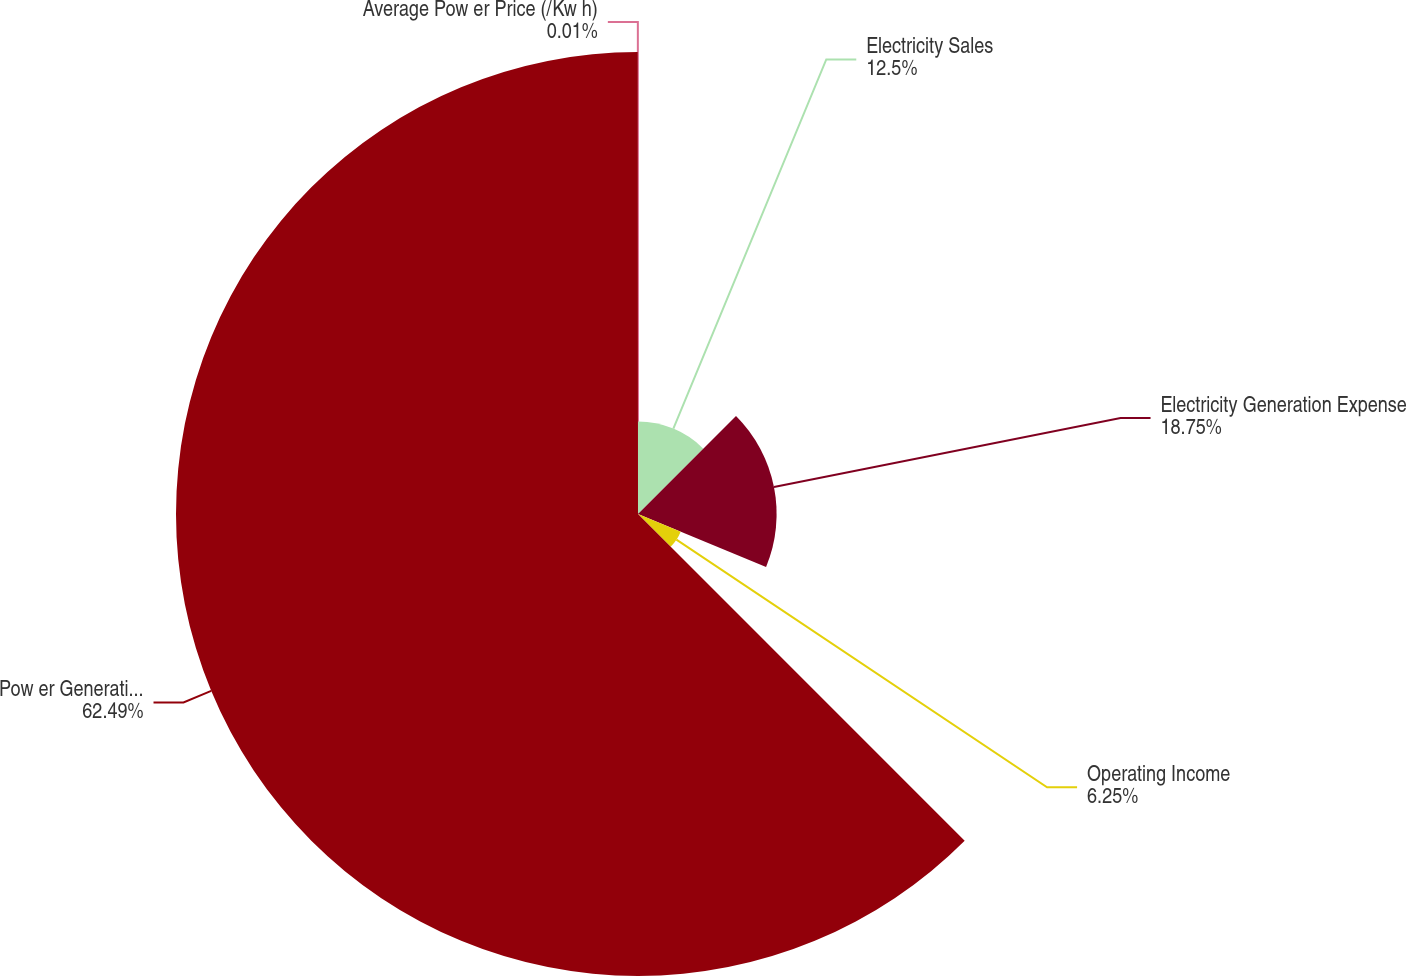<chart> <loc_0><loc_0><loc_500><loc_500><pie_chart><fcel>Electricity Sales<fcel>Electricity Generation Expense<fcel>Operating Income<fcel>Pow er Generation (GW)<fcel>Average Pow er Price (/Kw h)<nl><fcel>12.5%<fcel>18.75%<fcel>6.25%<fcel>62.49%<fcel>0.01%<nl></chart> 